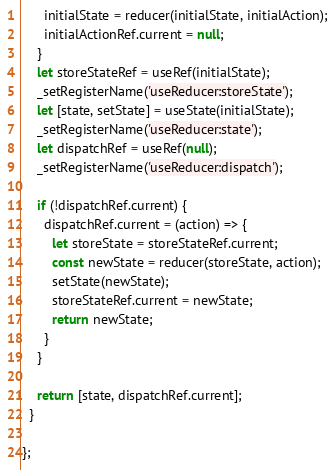Convert code to text. <code><loc_0><loc_0><loc_500><loc_500><_JavaScript_>      initialState = reducer(initialState, initialAction);
      initialActionRef.current = null;
    }
    let storeStateRef = useRef(initialState);
    _setRegisterName('useReducer:storeState');
    let [state, setState] = useState(initialState);
    _setRegisterName('useReducer:state');
    let dispatchRef = useRef(null);
    _setRegisterName('useReducer:dispatch');

    if (!dispatchRef.current) {
      dispatchRef.current = (action) => {
        let storeState = storeStateRef.current;
        const newState = reducer(storeState, action);
        setState(newState);
        storeStateRef.current = newState;
        return newState;
      }
    }

    return [state, dispatchRef.current];
  }

};
</code> 